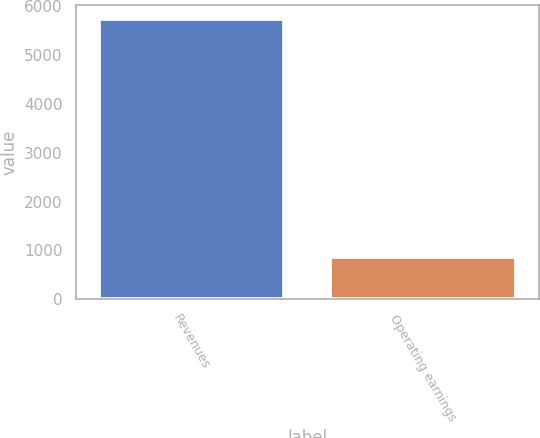<chart> <loc_0><loc_0><loc_500><loc_500><bar_chart><fcel>Revenues<fcel>Operating earnings<nl><fcel>5732<fcel>862<nl></chart> 